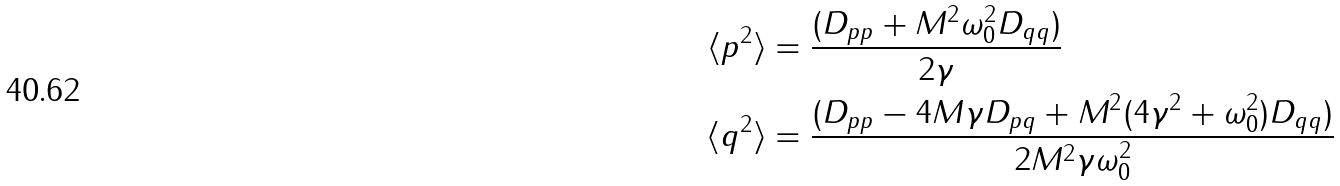<formula> <loc_0><loc_0><loc_500><loc_500>\langle p ^ { 2 } \rangle & = \frac { ( D _ { p p } + M ^ { 2 } \omega _ { 0 } ^ { 2 } D _ { q q } ) } { 2 \gamma } \\ \langle q ^ { 2 } \rangle & = \frac { ( D _ { p p } - 4 M \gamma D _ { p q } + M ^ { 2 } ( 4 \gamma ^ { 2 } + \omega _ { 0 } ^ { 2 } ) D _ { q q } ) } { 2 M ^ { 2 } \gamma \omega _ { 0 } ^ { 2 } }</formula> 